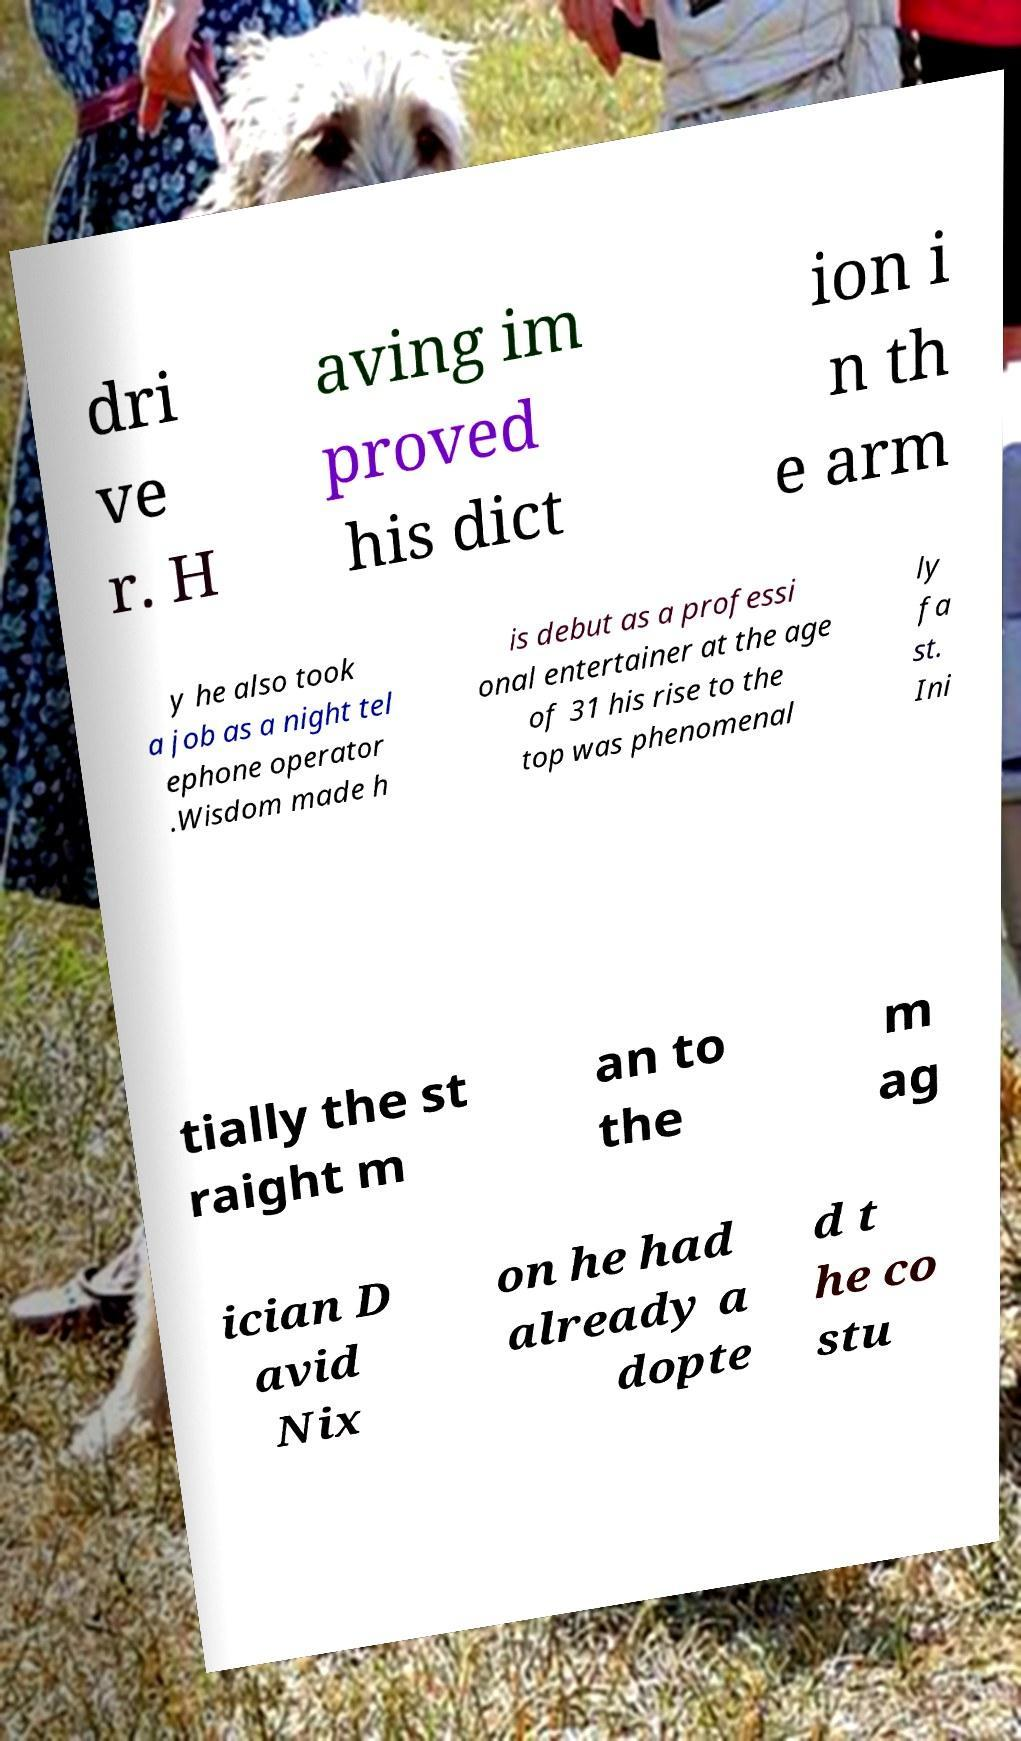There's text embedded in this image that I need extracted. Can you transcribe it verbatim? dri ve r. H aving im proved his dict ion i n th e arm y he also took a job as a night tel ephone operator .Wisdom made h is debut as a professi onal entertainer at the age of 31 his rise to the top was phenomenal ly fa st. Ini tially the st raight m an to the m ag ician D avid Nix on he had already a dopte d t he co stu 